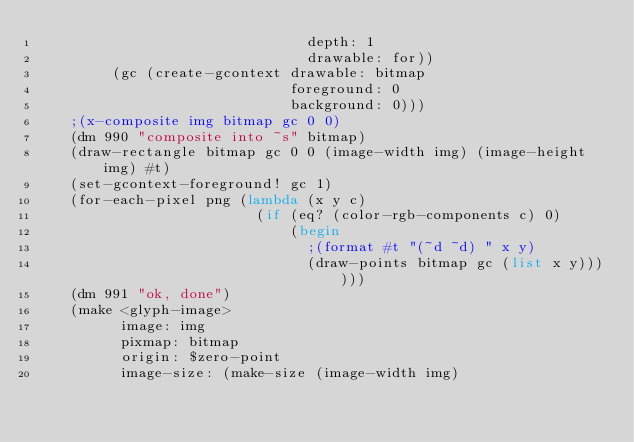Convert code to text. <code><loc_0><loc_0><loc_500><loc_500><_Scheme_>                                depth: 1
                                drawable: for))
         (gc (create-gcontext drawable: bitmap
                              foreground: 0
                              background: 0)))
    ;(x-composite img bitmap gc 0 0)
    (dm 990 "composite into ~s" bitmap)
    (draw-rectangle bitmap gc 0 0 (image-width img) (image-height img) #t)
    (set-gcontext-foreground! gc 1)
    (for-each-pixel png (lambda (x y c)
                          (if (eq? (color-rgb-components c) 0)
                              (begin
                                ;(format #t "(~d ~d) " x y)
                                (draw-points bitmap gc (list x y))))))
    (dm 991 "ok, done")
    (make <glyph-image>
          image: img
          pixmap: bitmap
          origin: $zero-point
          image-size: (make-size (image-width img)</code> 